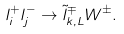Convert formula to latex. <formula><loc_0><loc_0><loc_500><loc_500>l _ { i } ^ { + } l _ { j } ^ { - } \rightarrow \tilde { l } _ { k , L } ^ { \mp } W ^ { \pm } .</formula> 